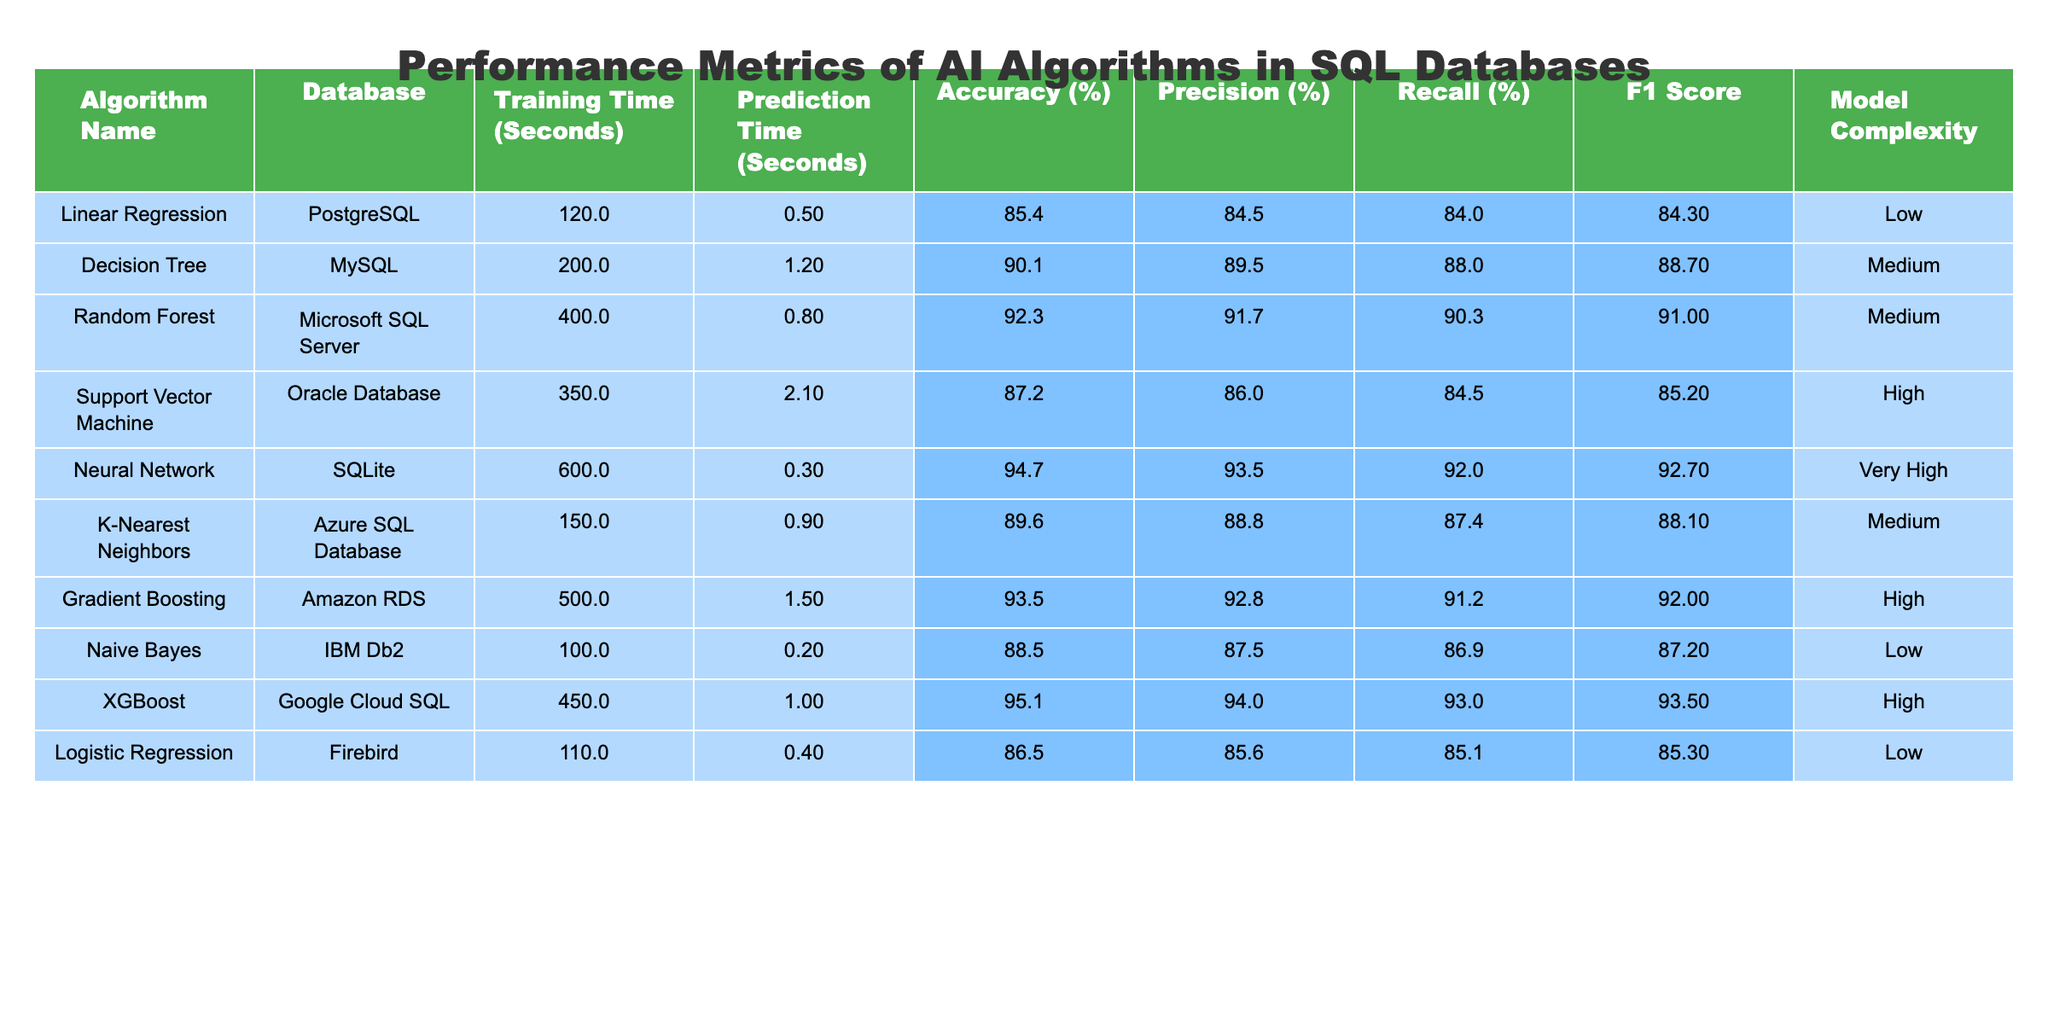What is the accuracy of the Neural Network algorithm? The accuracy value for the Neural Network listed in the table is 94.7%.
Answer: 94.7% Which algorithm took the longest to train? The algorithm with the longest training time is the Neural Network, which took 600 seconds.
Answer: Neural Network What is the difference in prediction time between the Random Forest and K-Nearest Neighbors algorithms? The prediction time for Random Forest is 0.8 seconds, and for K-Nearest Neighbors, it is 0.9 seconds. The difference is 0.9 - 0.8 = 0.1 seconds.
Answer: 0.1 seconds Is the F1 Score for XGBoost higher than that of Support Vector Machine? The F1 Score for XGBoost is 93.5, and for Support Vector Machine, it is 85.2. Since 93.5 is greater than 85.2, the statement is true.
Answer: Yes Which database is associated with the highest precision percentage? By referring to the table, Neural Network has the highest precision of 93.5% associated with SQLite.
Answer: SQLite What is the average training time of all algorithms? The training times are 120, 200, 400, 350, 600, 150, 500, 100, 450, and 110 seconds. The sum is 2630 seconds, and there are 10 algorithms, so the average is 2630 / 10 = 263 seconds.
Answer: 263 seconds Which algorithm has the highest model complexity, and what is its accuracy? The algorithm with the highest model complexity is the Neural Network, and its accuracy is 94.7%.
Answer: Neural Network, 94.7% Are there any algorithms with low complexity achieving an accuracy above 85%? Linear Regression and Naive Bayes are both low complexity algorithms, with accuracies of 85.4% and 88.5%, respectively. Therefore, the answer is yes.
Answer: Yes How does the recall of Random Forest compare to that of Gradient Boosting? The recall for Random Forest is 90.3%, and for Gradient Boosting, it is 91.2%. Gradient Boosting's recall is higher than that of Random Forest, so it is better.
Answer: Gradient Boosting is higher What algorithm shows an improvement in precision when comparing Decision Tree to Random Forest? The precision for Decision Tree is 89.5%, while for Random Forest, it is 91.7%. Since 91.7% is greater than 89.5%, Random Forest shows improvement.
Answer: Yes 